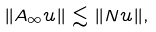Convert formula to latex. <formula><loc_0><loc_0><loc_500><loc_500>\| A _ { \infty } u \| \lesssim \| N u \| ,</formula> 